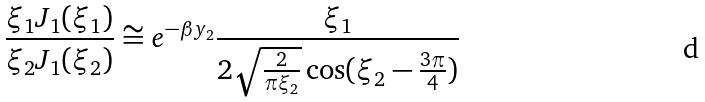Convert formula to latex. <formula><loc_0><loc_0><loc_500><loc_500>\frac { \xi _ { 1 } J _ { 1 } ( \xi _ { 1 } ) } { \xi _ { 2 } J _ { 1 } ( \xi _ { 2 } ) } \cong e ^ { - \beta y _ { 2 } } \frac { \xi _ { 1 } } { 2 \sqrt { \frac { 2 } { \pi \xi _ { 2 } } } \cos ( \xi _ { 2 } - \frac { 3 \pi } { 4 } ) }</formula> 